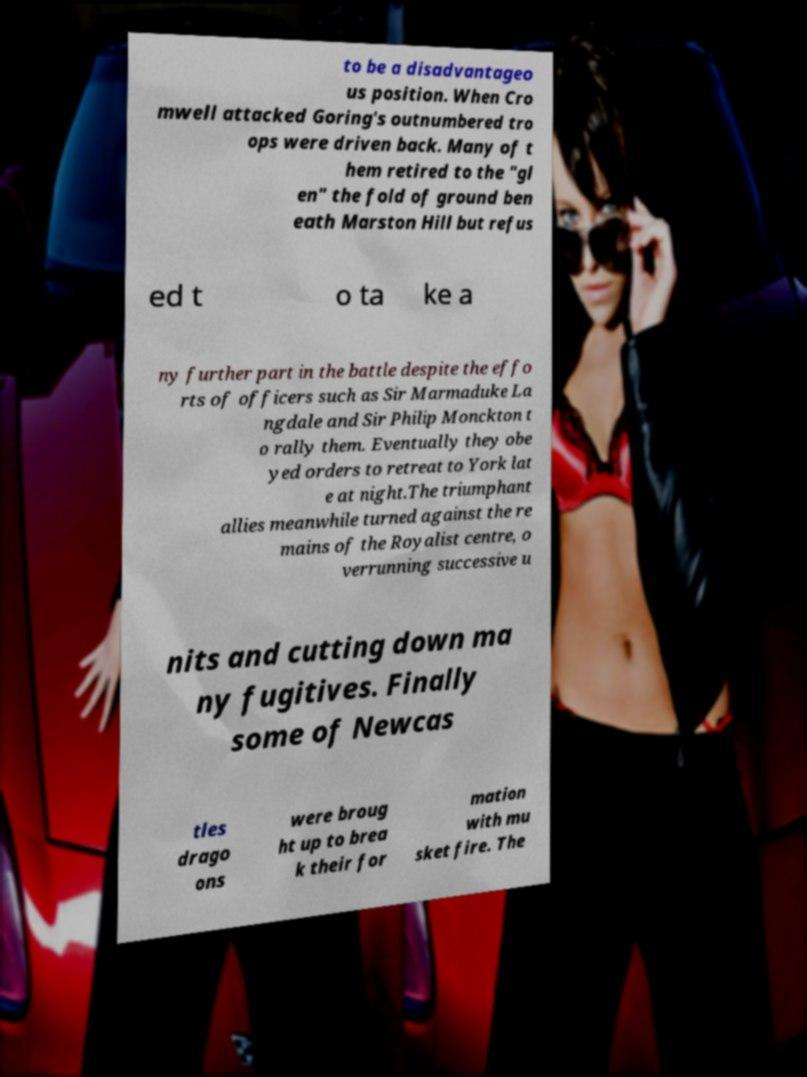Please read and relay the text visible in this image. What does it say? to be a disadvantageo us position. When Cro mwell attacked Goring's outnumbered tro ops were driven back. Many of t hem retired to the "gl en" the fold of ground ben eath Marston Hill but refus ed t o ta ke a ny further part in the battle despite the effo rts of officers such as Sir Marmaduke La ngdale and Sir Philip Monckton t o rally them. Eventually they obe yed orders to retreat to York lat e at night.The triumphant allies meanwhile turned against the re mains of the Royalist centre, o verrunning successive u nits and cutting down ma ny fugitives. Finally some of Newcas tles drago ons were broug ht up to brea k their for mation with mu sket fire. The 